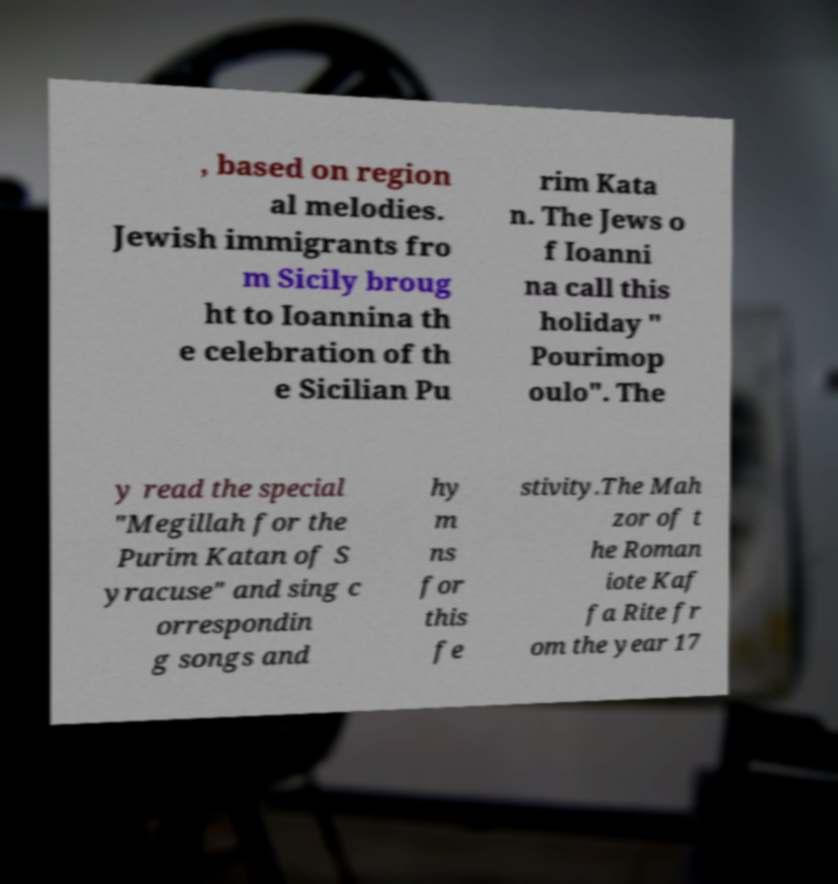Could you assist in decoding the text presented in this image and type it out clearly? , based on region al melodies. Jewish immigrants fro m Sicily broug ht to Ioannina th e celebration of th e Sicilian Pu rim Kata n. The Jews o f Ioanni na call this holiday " Pourimop oulo". The y read the special "Megillah for the Purim Katan of S yracuse" and sing c orrespondin g songs and hy m ns for this fe stivity.The Mah zor of t he Roman iote Kaf fa Rite fr om the year 17 